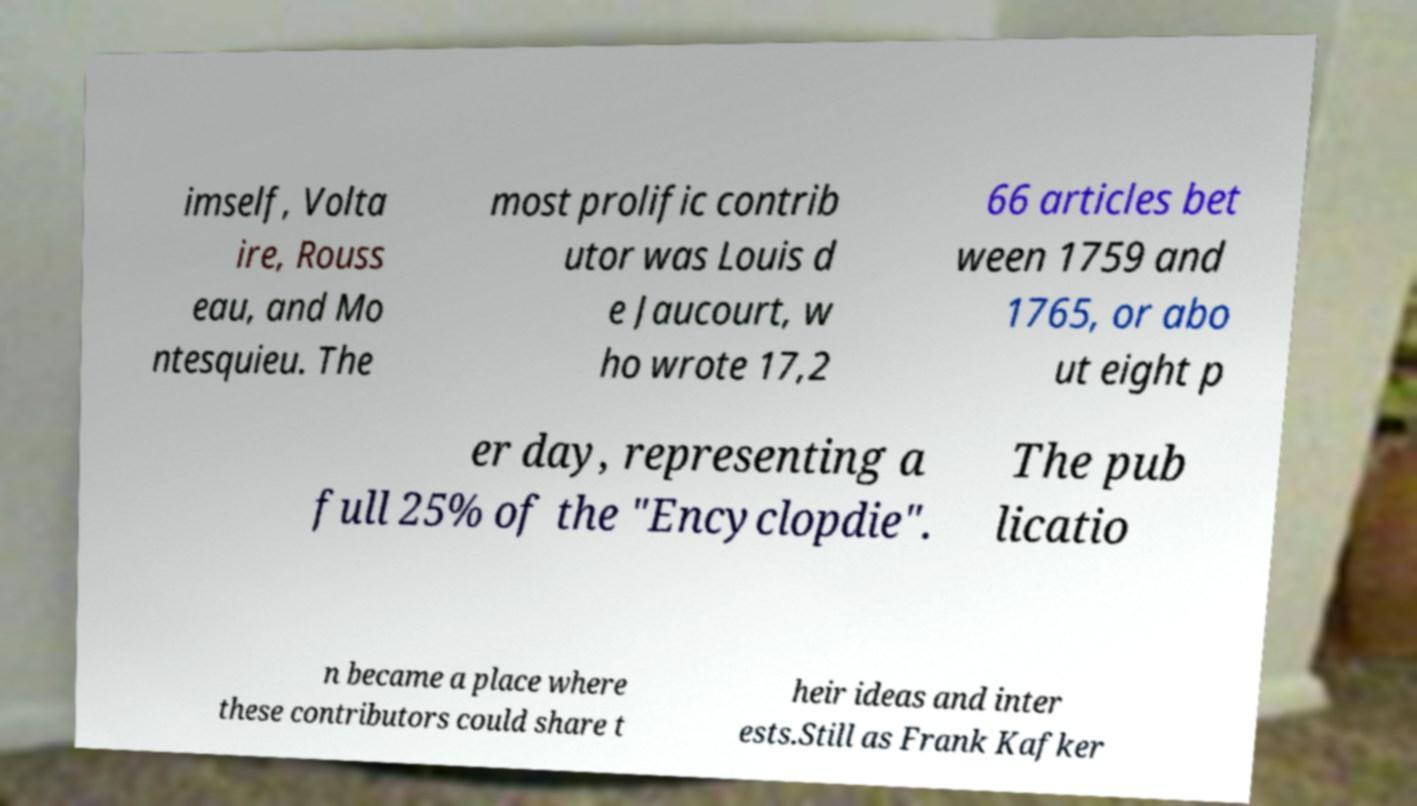What messages or text are displayed in this image? I need them in a readable, typed format. imself, Volta ire, Rouss eau, and Mo ntesquieu. The most prolific contrib utor was Louis d e Jaucourt, w ho wrote 17,2 66 articles bet ween 1759 and 1765, or abo ut eight p er day, representing a full 25% of the "Encyclopdie". The pub licatio n became a place where these contributors could share t heir ideas and inter ests.Still as Frank Kafker 